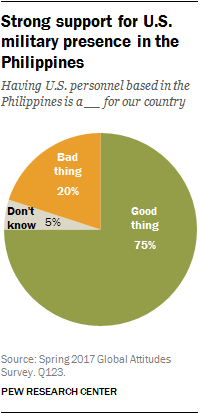Specify some key components in this picture. The color with the highest value in the pie chart is green. It is not expected that the value of bad things and not knowing will be greater than the good things if they are added. 